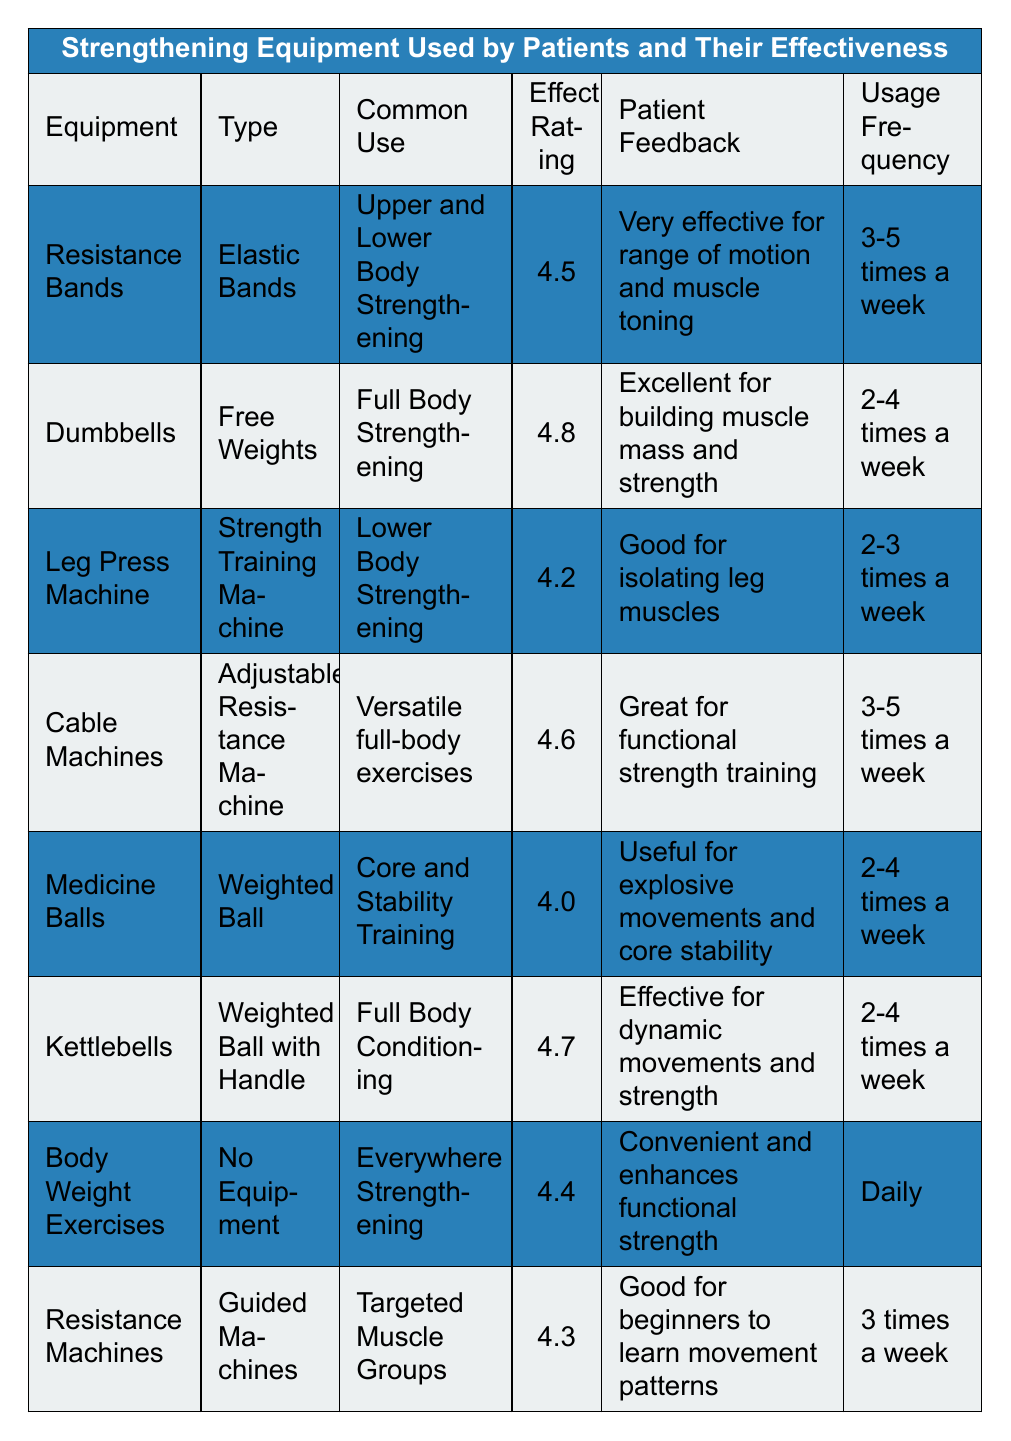What is the effectiveness rating of Dumbbells? By referring to the table, the effectiveness rating for Dumbbells is directly listed under the "Effectiveness Rating" column. It shows a value of 4.8.
Answer: 4.8 How frequently do patients use Resistance Bands? The table indicates that Resistance Bands are used 3-5 times a week, which is specified in the "Usage Frequency" column.
Answer: 3-5 times a week Which piece of equipment has the highest effectiveness rating? By comparing the effectiveness ratings for all the equipment listed in the table, Dumbbells have the highest rating of 4.8.
Answer: Dumbbells Is the patient feedback for Kettlebells positive? Looking at the "Patient Feedback" column for Kettlebells, it states that they are "Effective for dynamic movements and strength," which suggests positive feedback.
Answer: Yes What is the average effectiveness rating of the equipment listed in the table? The effectiveness ratings are 4.5, 4.8, 4.2, 4.6, 4.0, 4.7, 4.4, and 4.3. Adding them together gives a total of 36.5. There are 8 pieces of equipment, so the average is 36.5 divided by 8, which equals 4.5625.
Answer: 4.56 Which equipment has the lowest effectiveness rating? By examining the effectiveness ratings, Medicine Balls have the lowest rating at 4.0.
Answer: Medicine Balls Is the Usage Frequency for Body Weight Exercises daily? The "Usage Frequency" column for Body Weight Exercises indicates "Daily," confirming the question.
Answer: Yes If a patient uses Cable Machines 5 times a week, how does that compare to Resistance Machines? Cable Machines are recommended for use 3-5 times a week, while Resistance Machines are used 3 times a week. Since the upper limit for Cable Machines is higher, they are suggested more frequently.
Answer: More frequent What are the common uses for Medicine Balls and Kettlebells? According to the table, Medicine Balls are used for "Core and Stability Training," while Kettlebells are for "Full Body Conditioning." This shows different focus areas for each equipment.
Answer: Different focus areas If a patient combined the frequency of usage for Dumbbells and Leg Press Machine, how many times a week would that be? For Dumbbells, the frequency is 2-4 times a week, and for the Leg Press Machine, it is 2-3 times a week. The combined frequency can be from a minimum of 4 times (2+2) to a maximum of 7 times (4+3).
Answer: 4 to 7 times a week 